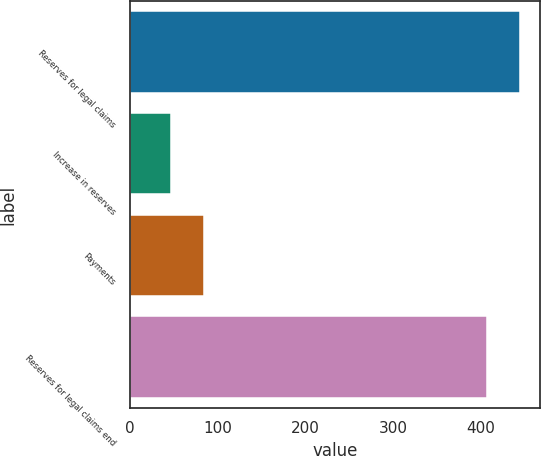Convert chart to OTSL. <chart><loc_0><loc_0><loc_500><loc_500><bar_chart><fcel>Reserves for legal claims<fcel>Increase in reserves<fcel>Payments<fcel>Reserves for legal claims end<nl><fcel>445.52<fcel>46.4<fcel>83.82<fcel>408.1<nl></chart> 